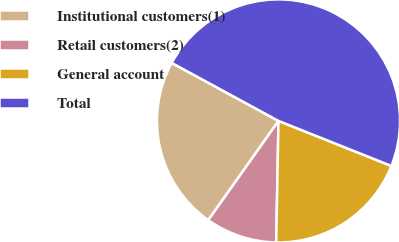Convert chart. <chart><loc_0><loc_0><loc_500><loc_500><pie_chart><fcel>Institutional customers(1)<fcel>Retail customers(2)<fcel>General account<fcel>Total<nl><fcel>23.12%<fcel>9.5%<fcel>19.26%<fcel>48.12%<nl></chart> 